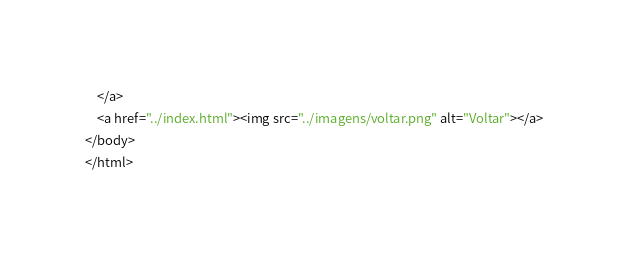Convert code to text. <code><loc_0><loc_0><loc_500><loc_500><_HTML_>    </a>
    <a href="../index.html"><img src="../imagens/voltar.png" alt="Voltar"></a>
</body>
</html></code> 